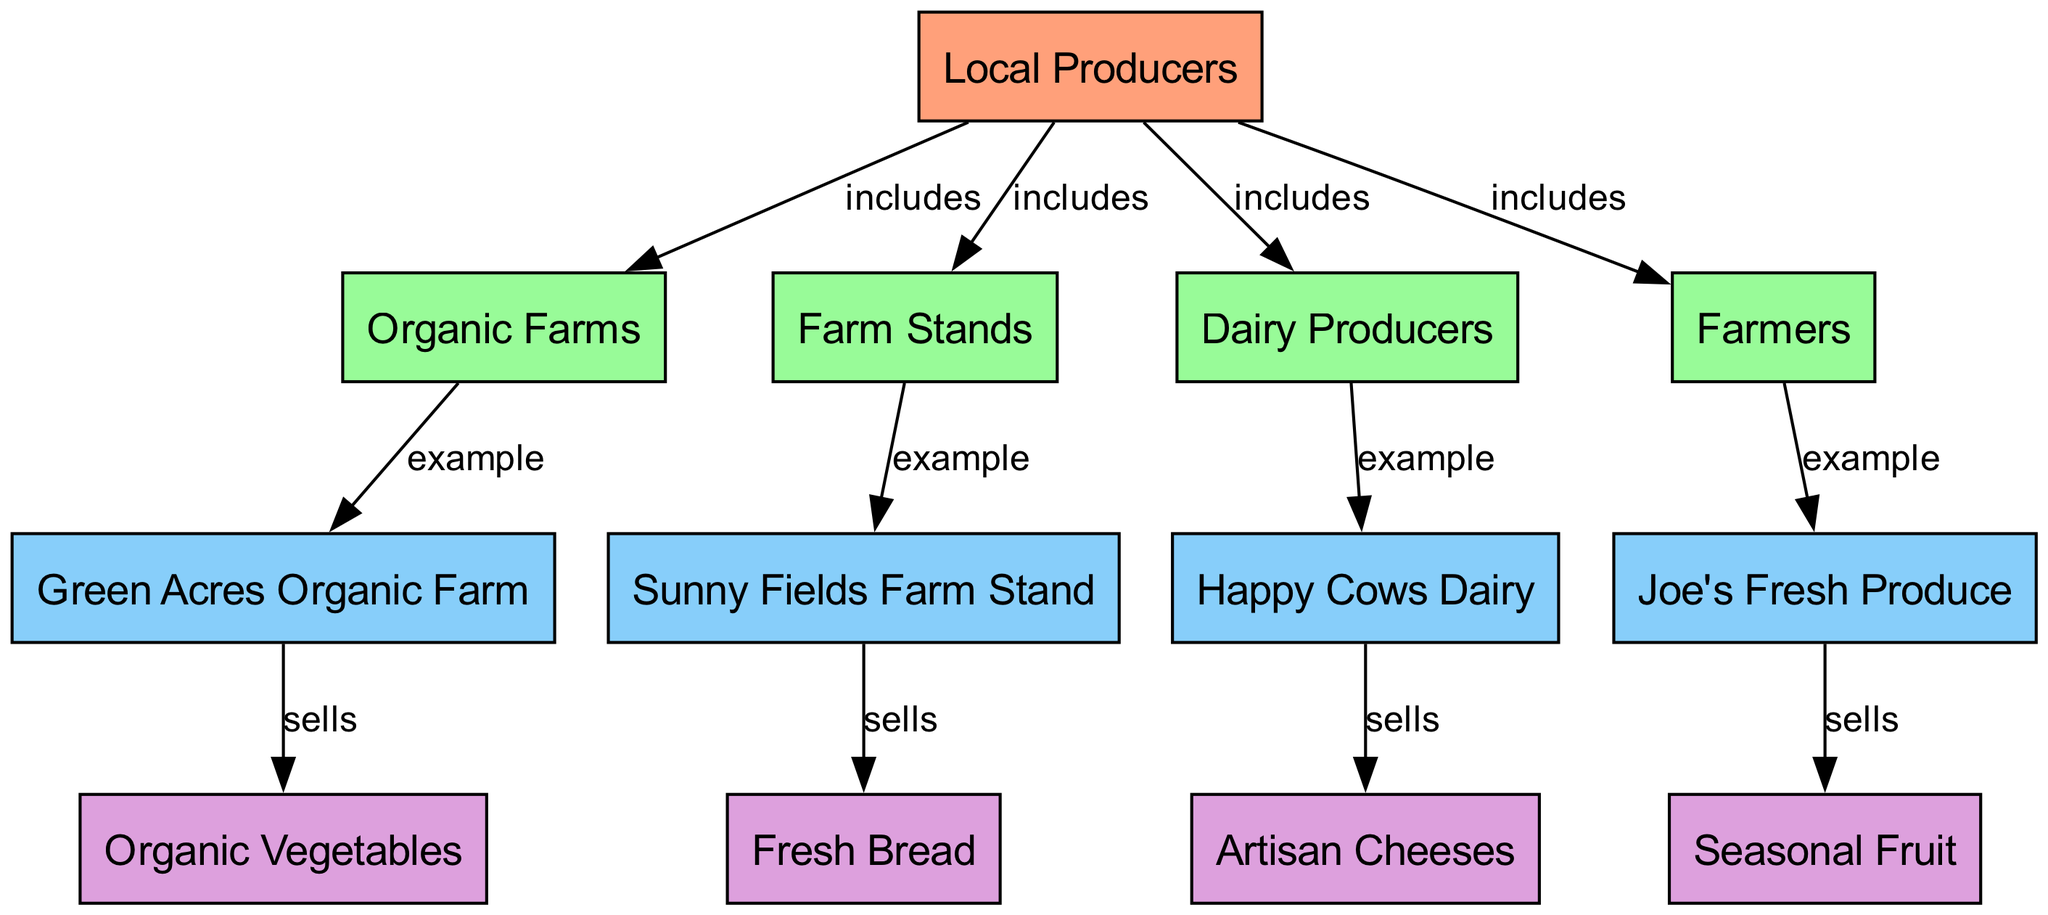What are the four categories of local producers? The diagram shows "Local Producers" at the top, connected to four subcategories: "Organic Farms," "Farm Stands," "Dairy Producers," and "Farmers." These elements make up the main categories under local producers.
Answer: Organic Farms, Farm Stands, Dairy Producers, Farmers Which farm is an example of an organic farm? The diagram connects "Organic Farms" to "Green Acres Organic Farm" as an example. This indicates that Green Acres is a representative of the organic farms category.
Answer: Green Acres Organic Farm What type of items does Happy Cows Dairy sell? Following the edges from "Happy Cows Dairy," we see that it is indicated to "sells" "Artisan Cheeses." This means that the primary item sold by this dairy producer is artisan cheeses.
Answer: Artisan Cheeses How many local producers are represented in the diagram? The diagram identifies four subcategories of local producers: "Organic Farms," "Farm Stands," "Dairy Producers," and "Farmers." Each of these categories has examples listed under them; hence, while the categories group the producers, the total count here should reflect those categories. Based on the subcategories, there are four types of local producers noted.
Answer: 4 Which farm stand sells fresh bread? In the diagram, "Farm Stands" points to "Sunny Fields Farm Stand," which is noted to sell "Fresh Bread." This means the specific farm stand responsible for selling that item is Sunny Fields.
Answer: Sunny Fields Farm Stand What is the relationship between Joe's Fresh Produce and seasonal fruit? The diagram illustrates that "Joe's Fresh Produce" has an edge labeled "sells" leading to "Seasonal Fruit." This indicates the direct selling relationship between the farm and the specific item.
Answer: sells How many unique items are mentioned in the diagram? Examining the diagram, we see a total of four items listed: "Organic Vegetables," "Fresh Bread," "Artisan Cheeses," and "Seasonal Fruit." Each is connected to various producers or stands, which totals to four unique items.
Answer: 4 Which type of producer sells organic vegetables? The diagram indicates that "Green Acres Organic Farm" sells "Organic Vegetables." This creates a direct relationship between the organic farm and the type of item it provides.
Answer: Green Acres Organic Farm 